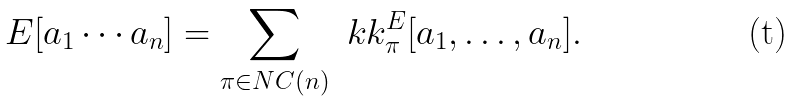Convert formula to latex. <formula><loc_0><loc_0><loc_500><loc_500>E [ a _ { 1 } \cdots a _ { n } ] = \sum _ { \pi \in N C ( n ) } \ k k _ { \pi } ^ { E } [ a _ { 1 } , \dots , a _ { n } ] .</formula> 